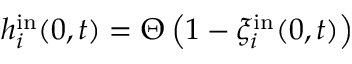<formula> <loc_0><loc_0><loc_500><loc_500>h _ { i } ^ { i n } ( 0 , t ) = \Theta \left ( 1 - \xi _ { i } ^ { i n } ( 0 , t ) \right )</formula> 